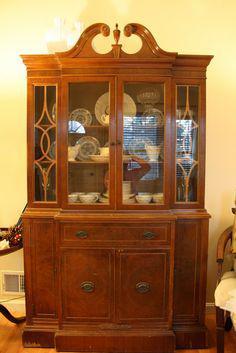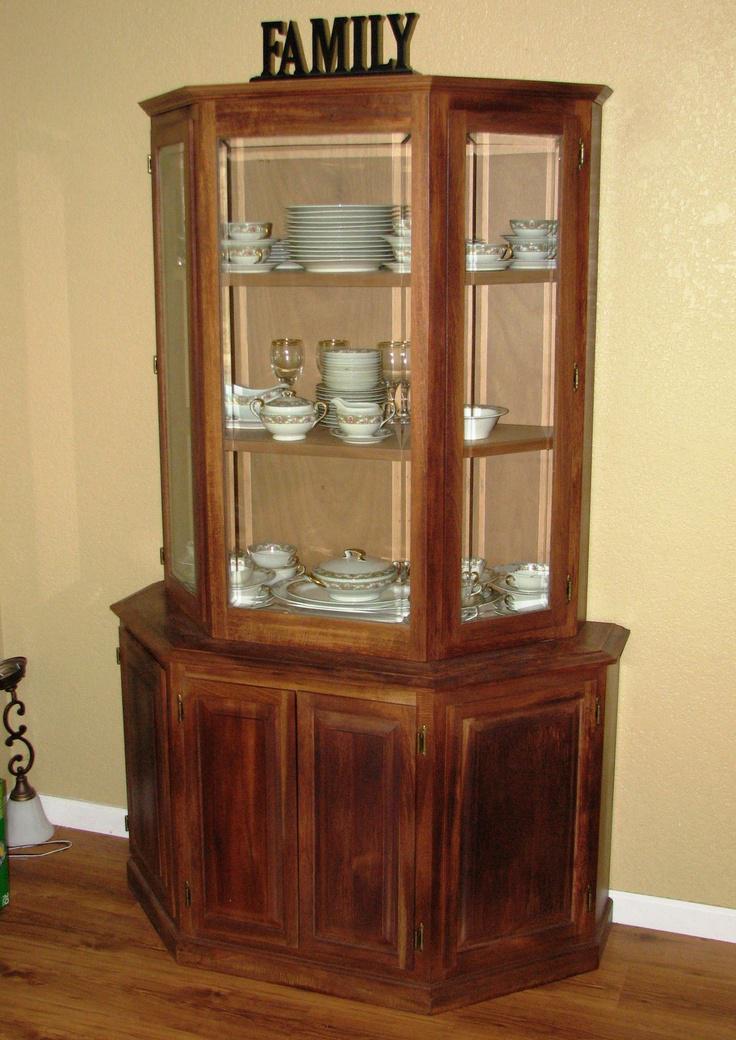The first image is the image on the left, the second image is the image on the right. Considering the images on both sides, is "There are four drawers on the cabinet in the image on the left." valid? Answer yes or no. No. 